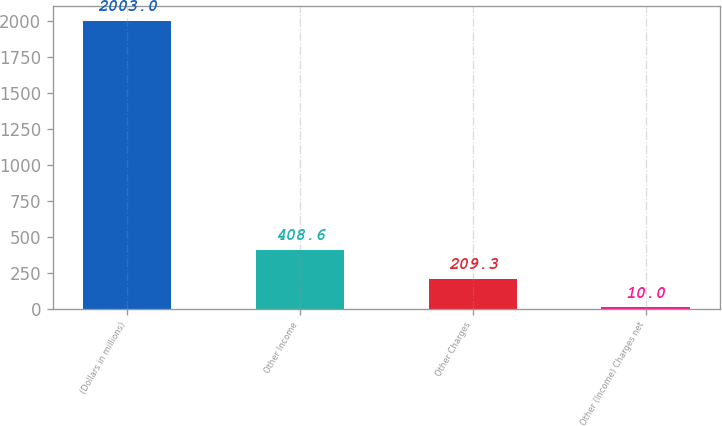Convert chart. <chart><loc_0><loc_0><loc_500><loc_500><bar_chart><fcel>(Dollars in millions)<fcel>Other Income<fcel>Other Charges<fcel>Other (Income) Charges net<nl><fcel>2003<fcel>408.6<fcel>209.3<fcel>10<nl></chart> 